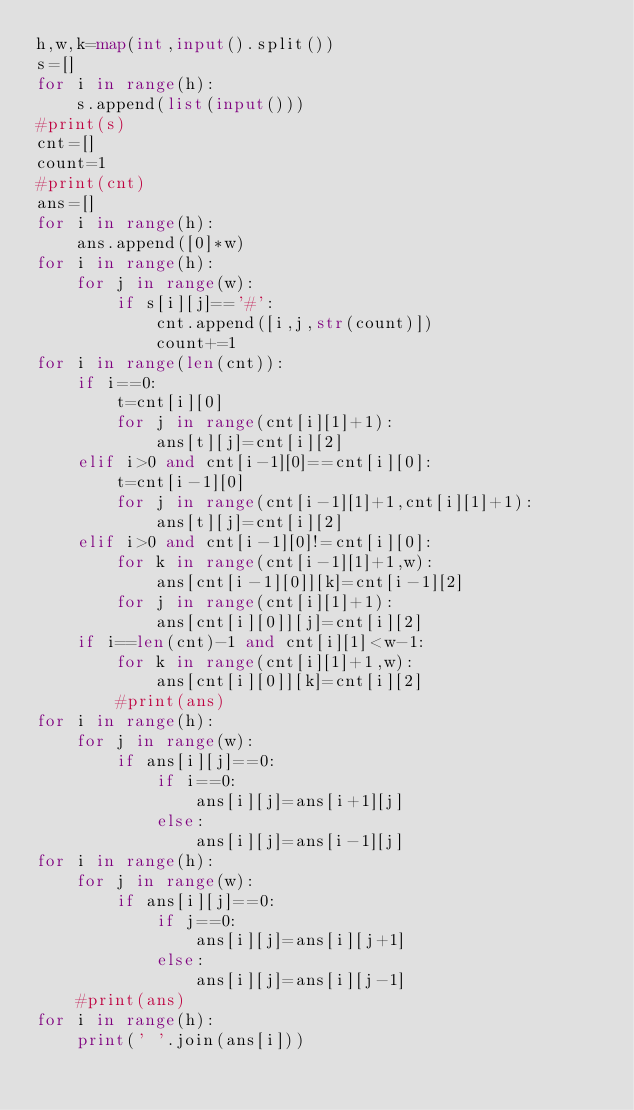Convert code to text. <code><loc_0><loc_0><loc_500><loc_500><_Python_>h,w,k=map(int,input().split())
s=[]
for i in range(h):
    s.append(list(input()))
#print(s)
cnt=[]
count=1
#print(cnt)
ans=[]
for i in range(h):
    ans.append([0]*w)
for i in range(h):
    for j in range(w):
        if s[i][j]=='#':
            cnt.append([i,j,str(count)])
            count+=1
for i in range(len(cnt)):
    if i==0:
        t=cnt[i][0]
        for j in range(cnt[i][1]+1):
            ans[t][j]=cnt[i][2]
    elif i>0 and cnt[i-1][0]==cnt[i][0]:
        t=cnt[i-1][0]
        for j in range(cnt[i-1][1]+1,cnt[i][1]+1):
            ans[t][j]=cnt[i][2]
    elif i>0 and cnt[i-1][0]!=cnt[i][0]:
        for k in range(cnt[i-1][1]+1,w):
            ans[cnt[i-1][0]][k]=cnt[i-1][2]
        for j in range(cnt[i][1]+1):
            ans[cnt[i][0]][j]=cnt[i][2]
    if i==len(cnt)-1 and cnt[i][1]<w-1:
        for k in range(cnt[i][1]+1,w):
            ans[cnt[i][0]][k]=cnt[i][2]
        #print(ans)
for i in range(h):
    for j in range(w):
        if ans[i][j]==0:
            if i==0:
                ans[i][j]=ans[i+1][j]
            else:
                ans[i][j]=ans[i-1][j]
for i in range(h):
    for j in range(w):
        if ans[i][j]==0:
            if j==0:
                ans[i][j]=ans[i][j+1]
            else:
                ans[i][j]=ans[i][j-1]
    #print(ans)                
for i in range(h):
    print(' '.join(ans[i]))
</code> 